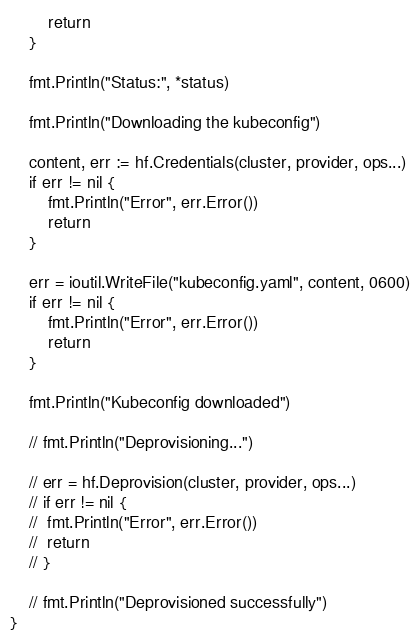<code> <loc_0><loc_0><loc_500><loc_500><_Go_>		return
	}

	fmt.Println("Status:", *status)

	fmt.Println("Downloading the kubeconfig")

	content, err := hf.Credentials(cluster, provider, ops...)
	if err != nil {
		fmt.Println("Error", err.Error())
		return
	}

	err = ioutil.WriteFile("kubeconfig.yaml", content, 0600)
	if err != nil {
		fmt.Println("Error", err.Error())
		return
	}

	fmt.Println("Kubeconfig downloaded")

	// fmt.Println("Deprovisioning...")

	// err = hf.Deprovision(cluster, provider, ops...)
	// if err != nil {
	// 	fmt.Println("Error", err.Error())
	// 	return
	// }

	// fmt.Println("Deprovisioned successfully")
}
</code> 